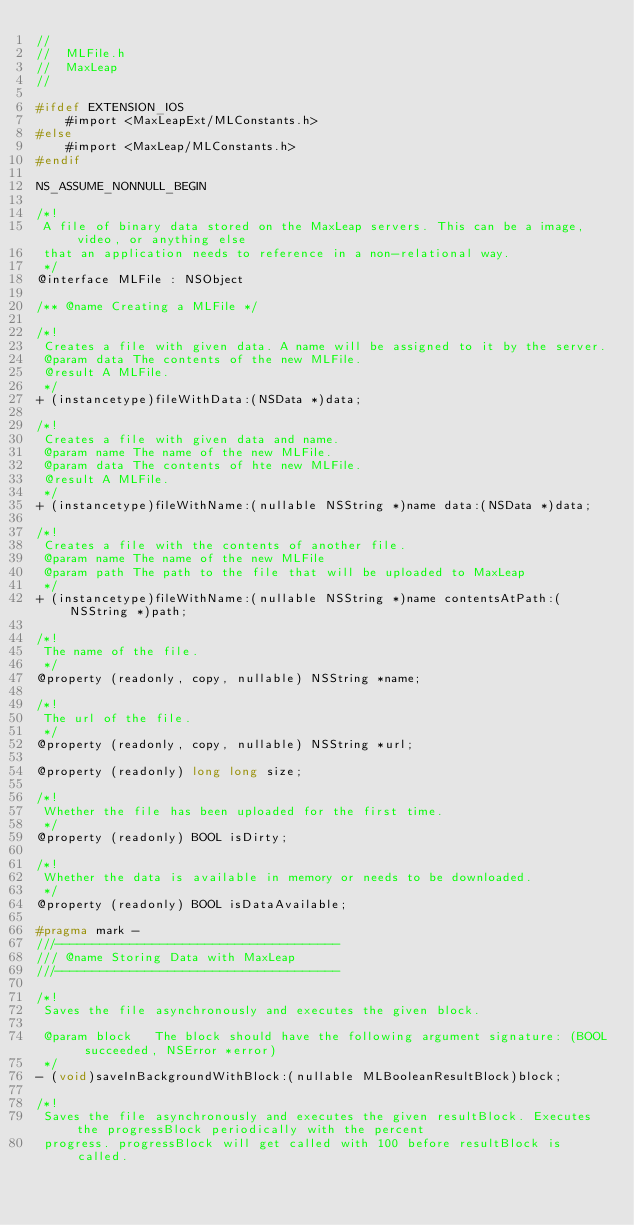Convert code to text. <code><loc_0><loc_0><loc_500><loc_500><_C_>//
//  MLFile.h
//  MaxLeap
//

#ifdef EXTENSION_IOS
    #import <MaxLeapExt/MLConstants.h>
#else
    #import <MaxLeap/MLConstants.h>
#endif

NS_ASSUME_NONNULL_BEGIN

/*!
 A file of binary data stored on the MaxLeap servers. This can be a image, video, or anything else
 that an application needs to reference in a non-relational way.
 */
@interface MLFile : NSObject

/** @name Creating a MLFile */

/*!
 Creates a file with given data. A name will be assigned to it by the server.
 @param data The contents of the new MLFile.
 @result A MLFile.
 */
+ (instancetype)fileWithData:(NSData *)data;

/*!
 Creates a file with given data and name.
 @param name The name of the new MLFile.
 @param data The contents of hte new MLFile.
 @result A MLFile.
 */
+ (instancetype)fileWithName:(nullable NSString *)name data:(NSData *)data;

/*!
 Creates a file with the contents of another file.
 @param name The name of the new MLFile
 @param path The path to the file that will be uploaded to MaxLeap
 */
+ (instancetype)fileWithName:(nullable NSString *)name contentsAtPath:(NSString *)path;

/*!
 The name of the file.
 */
@property (readonly, copy, nullable) NSString *name;

/*!
 The url of the file.
 */
@property (readonly, copy, nullable) NSString *url;

@property (readonly) long long size;

/*!
 Whether the file has been uploaded for the first time.
 */
@property (readonly) BOOL isDirty;

/*!
 Whether the data is available in memory or needs to be downloaded.
 */
@property (readonly) BOOL isDataAvailable;

#pragma mark -
///--------------------------------------
/// @name Storing Data with MaxLeap
///--------------------------------------

/*!
 Saves the file asynchronously and executes the given block.
 
 @param block   The block should have the following argument signature: (BOOL succeeded, NSError *error)
 */
- (void)saveInBackgroundWithBlock:(nullable MLBooleanResultBlock)block;

/*!
 Saves the file asynchronously and executes the given resultBlock. Executes the progressBlock periodically with the percent
 progress. progressBlock will get called with 100 before resultBlock is called.
 </code> 